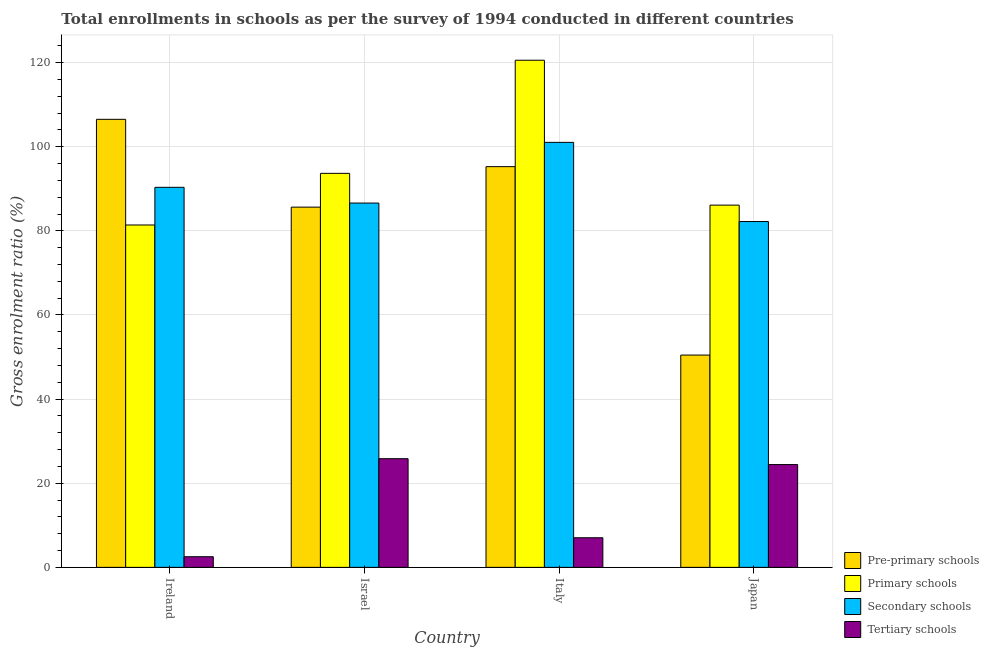How many groups of bars are there?
Keep it short and to the point. 4. Are the number of bars on each tick of the X-axis equal?
Provide a short and direct response. Yes. How many bars are there on the 3rd tick from the left?
Your answer should be compact. 4. How many bars are there on the 3rd tick from the right?
Make the answer very short. 4. What is the gross enrolment ratio in primary schools in Israel?
Provide a succinct answer. 93.68. Across all countries, what is the maximum gross enrolment ratio in pre-primary schools?
Provide a short and direct response. 106.52. Across all countries, what is the minimum gross enrolment ratio in secondary schools?
Provide a succinct answer. 82.22. In which country was the gross enrolment ratio in pre-primary schools maximum?
Make the answer very short. Ireland. In which country was the gross enrolment ratio in tertiary schools minimum?
Ensure brevity in your answer.  Ireland. What is the total gross enrolment ratio in tertiary schools in the graph?
Your answer should be very brief. 59.84. What is the difference between the gross enrolment ratio in tertiary schools in Israel and that in Japan?
Offer a terse response. 1.4. What is the difference between the gross enrolment ratio in tertiary schools in Italy and the gross enrolment ratio in secondary schools in Japan?
Keep it short and to the point. -75.18. What is the average gross enrolment ratio in tertiary schools per country?
Your answer should be compact. 14.96. What is the difference between the gross enrolment ratio in primary schools and gross enrolment ratio in pre-primary schools in Italy?
Provide a succinct answer. 25.3. In how many countries, is the gross enrolment ratio in tertiary schools greater than 60 %?
Provide a succinct answer. 0. What is the ratio of the gross enrolment ratio in secondary schools in Italy to that in Japan?
Offer a very short reply. 1.23. Is the gross enrolment ratio in secondary schools in Israel less than that in Japan?
Offer a very short reply. No. What is the difference between the highest and the second highest gross enrolment ratio in primary schools?
Provide a succinct answer. 26.9. What is the difference between the highest and the lowest gross enrolment ratio in secondary schools?
Provide a succinct answer. 18.82. Is the sum of the gross enrolment ratio in secondary schools in Israel and Japan greater than the maximum gross enrolment ratio in pre-primary schools across all countries?
Make the answer very short. Yes. Is it the case that in every country, the sum of the gross enrolment ratio in pre-primary schools and gross enrolment ratio in secondary schools is greater than the sum of gross enrolment ratio in tertiary schools and gross enrolment ratio in primary schools?
Offer a very short reply. No. What does the 2nd bar from the left in Japan represents?
Offer a terse response. Primary schools. What does the 3rd bar from the right in Ireland represents?
Your answer should be compact. Primary schools. How many bars are there?
Make the answer very short. 16. Are all the bars in the graph horizontal?
Offer a terse response. No. Does the graph contain grids?
Give a very brief answer. Yes. How many legend labels are there?
Your response must be concise. 4. How are the legend labels stacked?
Offer a very short reply. Vertical. What is the title of the graph?
Your answer should be very brief. Total enrollments in schools as per the survey of 1994 conducted in different countries. What is the Gross enrolment ratio (%) in Pre-primary schools in Ireland?
Provide a short and direct response. 106.52. What is the Gross enrolment ratio (%) in Primary schools in Ireland?
Give a very brief answer. 81.4. What is the Gross enrolment ratio (%) of Secondary schools in Ireland?
Offer a very short reply. 90.36. What is the Gross enrolment ratio (%) of Tertiary schools in Ireland?
Offer a terse response. 2.53. What is the Gross enrolment ratio (%) in Pre-primary schools in Israel?
Offer a terse response. 85.65. What is the Gross enrolment ratio (%) of Primary schools in Israel?
Give a very brief answer. 93.68. What is the Gross enrolment ratio (%) of Secondary schools in Israel?
Give a very brief answer. 86.62. What is the Gross enrolment ratio (%) in Tertiary schools in Israel?
Your answer should be very brief. 25.84. What is the Gross enrolment ratio (%) of Pre-primary schools in Italy?
Offer a very short reply. 95.27. What is the Gross enrolment ratio (%) of Primary schools in Italy?
Your answer should be very brief. 120.57. What is the Gross enrolment ratio (%) of Secondary schools in Italy?
Your answer should be compact. 101.04. What is the Gross enrolment ratio (%) of Tertiary schools in Italy?
Your answer should be very brief. 7.04. What is the Gross enrolment ratio (%) of Pre-primary schools in Japan?
Your answer should be compact. 50.47. What is the Gross enrolment ratio (%) of Primary schools in Japan?
Offer a very short reply. 86.13. What is the Gross enrolment ratio (%) in Secondary schools in Japan?
Provide a short and direct response. 82.22. What is the Gross enrolment ratio (%) of Tertiary schools in Japan?
Your answer should be very brief. 24.44. Across all countries, what is the maximum Gross enrolment ratio (%) of Pre-primary schools?
Ensure brevity in your answer.  106.52. Across all countries, what is the maximum Gross enrolment ratio (%) in Primary schools?
Provide a succinct answer. 120.57. Across all countries, what is the maximum Gross enrolment ratio (%) of Secondary schools?
Your answer should be very brief. 101.04. Across all countries, what is the maximum Gross enrolment ratio (%) of Tertiary schools?
Offer a very short reply. 25.84. Across all countries, what is the minimum Gross enrolment ratio (%) in Pre-primary schools?
Provide a succinct answer. 50.47. Across all countries, what is the minimum Gross enrolment ratio (%) of Primary schools?
Ensure brevity in your answer.  81.4. Across all countries, what is the minimum Gross enrolment ratio (%) of Secondary schools?
Provide a succinct answer. 82.22. Across all countries, what is the minimum Gross enrolment ratio (%) of Tertiary schools?
Give a very brief answer. 2.53. What is the total Gross enrolment ratio (%) of Pre-primary schools in the graph?
Offer a terse response. 337.91. What is the total Gross enrolment ratio (%) in Primary schools in the graph?
Provide a short and direct response. 381.77. What is the total Gross enrolment ratio (%) in Secondary schools in the graph?
Make the answer very short. 360.24. What is the total Gross enrolment ratio (%) of Tertiary schools in the graph?
Provide a succinct answer. 59.84. What is the difference between the Gross enrolment ratio (%) of Pre-primary schools in Ireland and that in Israel?
Make the answer very short. 20.88. What is the difference between the Gross enrolment ratio (%) of Primary schools in Ireland and that in Israel?
Ensure brevity in your answer.  -12.28. What is the difference between the Gross enrolment ratio (%) in Secondary schools in Ireland and that in Israel?
Make the answer very short. 3.74. What is the difference between the Gross enrolment ratio (%) in Tertiary schools in Ireland and that in Israel?
Your answer should be very brief. -23.31. What is the difference between the Gross enrolment ratio (%) of Pre-primary schools in Ireland and that in Italy?
Your answer should be compact. 11.25. What is the difference between the Gross enrolment ratio (%) of Primary schools in Ireland and that in Italy?
Keep it short and to the point. -39.17. What is the difference between the Gross enrolment ratio (%) in Secondary schools in Ireland and that in Italy?
Offer a terse response. -10.69. What is the difference between the Gross enrolment ratio (%) in Tertiary schools in Ireland and that in Italy?
Give a very brief answer. -4.51. What is the difference between the Gross enrolment ratio (%) of Pre-primary schools in Ireland and that in Japan?
Give a very brief answer. 56.05. What is the difference between the Gross enrolment ratio (%) in Primary schools in Ireland and that in Japan?
Your answer should be very brief. -4.72. What is the difference between the Gross enrolment ratio (%) in Secondary schools in Ireland and that in Japan?
Provide a short and direct response. 8.13. What is the difference between the Gross enrolment ratio (%) in Tertiary schools in Ireland and that in Japan?
Give a very brief answer. -21.91. What is the difference between the Gross enrolment ratio (%) of Pre-primary schools in Israel and that in Italy?
Give a very brief answer. -9.62. What is the difference between the Gross enrolment ratio (%) in Primary schools in Israel and that in Italy?
Offer a terse response. -26.9. What is the difference between the Gross enrolment ratio (%) of Secondary schools in Israel and that in Italy?
Give a very brief answer. -14.43. What is the difference between the Gross enrolment ratio (%) of Tertiary schools in Israel and that in Italy?
Ensure brevity in your answer.  18.8. What is the difference between the Gross enrolment ratio (%) in Pre-primary schools in Israel and that in Japan?
Make the answer very short. 35.17. What is the difference between the Gross enrolment ratio (%) of Primary schools in Israel and that in Japan?
Keep it short and to the point. 7.55. What is the difference between the Gross enrolment ratio (%) in Secondary schools in Israel and that in Japan?
Ensure brevity in your answer.  4.4. What is the difference between the Gross enrolment ratio (%) of Tertiary schools in Israel and that in Japan?
Make the answer very short. 1.4. What is the difference between the Gross enrolment ratio (%) of Pre-primary schools in Italy and that in Japan?
Keep it short and to the point. 44.8. What is the difference between the Gross enrolment ratio (%) in Primary schools in Italy and that in Japan?
Provide a succinct answer. 34.45. What is the difference between the Gross enrolment ratio (%) of Secondary schools in Italy and that in Japan?
Make the answer very short. 18.82. What is the difference between the Gross enrolment ratio (%) of Tertiary schools in Italy and that in Japan?
Provide a succinct answer. -17.4. What is the difference between the Gross enrolment ratio (%) in Pre-primary schools in Ireland and the Gross enrolment ratio (%) in Primary schools in Israel?
Give a very brief answer. 12.85. What is the difference between the Gross enrolment ratio (%) in Pre-primary schools in Ireland and the Gross enrolment ratio (%) in Secondary schools in Israel?
Your answer should be compact. 19.91. What is the difference between the Gross enrolment ratio (%) in Pre-primary schools in Ireland and the Gross enrolment ratio (%) in Tertiary schools in Israel?
Make the answer very short. 80.69. What is the difference between the Gross enrolment ratio (%) of Primary schools in Ireland and the Gross enrolment ratio (%) of Secondary schools in Israel?
Ensure brevity in your answer.  -5.22. What is the difference between the Gross enrolment ratio (%) in Primary schools in Ireland and the Gross enrolment ratio (%) in Tertiary schools in Israel?
Your answer should be very brief. 55.57. What is the difference between the Gross enrolment ratio (%) in Secondary schools in Ireland and the Gross enrolment ratio (%) in Tertiary schools in Israel?
Give a very brief answer. 64.52. What is the difference between the Gross enrolment ratio (%) in Pre-primary schools in Ireland and the Gross enrolment ratio (%) in Primary schools in Italy?
Offer a very short reply. -14.05. What is the difference between the Gross enrolment ratio (%) of Pre-primary schools in Ireland and the Gross enrolment ratio (%) of Secondary schools in Italy?
Your answer should be compact. 5.48. What is the difference between the Gross enrolment ratio (%) in Pre-primary schools in Ireland and the Gross enrolment ratio (%) in Tertiary schools in Italy?
Keep it short and to the point. 99.49. What is the difference between the Gross enrolment ratio (%) of Primary schools in Ireland and the Gross enrolment ratio (%) of Secondary schools in Italy?
Provide a short and direct response. -19.64. What is the difference between the Gross enrolment ratio (%) of Primary schools in Ireland and the Gross enrolment ratio (%) of Tertiary schools in Italy?
Your answer should be compact. 74.36. What is the difference between the Gross enrolment ratio (%) in Secondary schools in Ireland and the Gross enrolment ratio (%) in Tertiary schools in Italy?
Your response must be concise. 83.32. What is the difference between the Gross enrolment ratio (%) in Pre-primary schools in Ireland and the Gross enrolment ratio (%) in Primary schools in Japan?
Your answer should be compact. 20.4. What is the difference between the Gross enrolment ratio (%) of Pre-primary schools in Ireland and the Gross enrolment ratio (%) of Secondary schools in Japan?
Ensure brevity in your answer.  24.3. What is the difference between the Gross enrolment ratio (%) in Pre-primary schools in Ireland and the Gross enrolment ratio (%) in Tertiary schools in Japan?
Make the answer very short. 82.09. What is the difference between the Gross enrolment ratio (%) in Primary schools in Ireland and the Gross enrolment ratio (%) in Secondary schools in Japan?
Make the answer very short. -0.82. What is the difference between the Gross enrolment ratio (%) of Primary schools in Ireland and the Gross enrolment ratio (%) of Tertiary schools in Japan?
Provide a succinct answer. 56.96. What is the difference between the Gross enrolment ratio (%) of Secondary schools in Ireland and the Gross enrolment ratio (%) of Tertiary schools in Japan?
Give a very brief answer. 65.92. What is the difference between the Gross enrolment ratio (%) of Pre-primary schools in Israel and the Gross enrolment ratio (%) of Primary schools in Italy?
Keep it short and to the point. -34.93. What is the difference between the Gross enrolment ratio (%) of Pre-primary schools in Israel and the Gross enrolment ratio (%) of Secondary schools in Italy?
Offer a very short reply. -15.4. What is the difference between the Gross enrolment ratio (%) in Pre-primary schools in Israel and the Gross enrolment ratio (%) in Tertiary schools in Italy?
Ensure brevity in your answer.  78.61. What is the difference between the Gross enrolment ratio (%) of Primary schools in Israel and the Gross enrolment ratio (%) of Secondary schools in Italy?
Make the answer very short. -7.37. What is the difference between the Gross enrolment ratio (%) in Primary schools in Israel and the Gross enrolment ratio (%) in Tertiary schools in Italy?
Make the answer very short. 86.64. What is the difference between the Gross enrolment ratio (%) in Secondary schools in Israel and the Gross enrolment ratio (%) in Tertiary schools in Italy?
Your answer should be compact. 79.58. What is the difference between the Gross enrolment ratio (%) in Pre-primary schools in Israel and the Gross enrolment ratio (%) in Primary schools in Japan?
Provide a short and direct response. -0.48. What is the difference between the Gross enrolment ratio (%) in Pre-primary schools in Israel and the Gross enrolment ratio (%) in Secondary schools in Japan?
Make the answer very short. 3.43. What is the difference between the Gross enrolment ratio (%) of Pre-primary schools in Israel and the Gross enrolment ratio (%) of Tertiary schools in Japan?
Offer a terse response. 61.21. What is the difference between the Gross enrolment ratio (%) of Primary schools in Israel and the Gross enrolment ratio (%) of Secondary schools in Japan?
Your response must be concise. 11.46. What is the difference between the Gross enrolment ratio (%) of Primary schools in Israel and the Gross enrolment ratio (%) of Tertiary schools in Japan?
Keep it short and to the point. 69.24. What is the difference between the Gross enrolment ratio (%) in Secondary schools in Israel and the Gross enrolment ratio (%) in Tertiary schools in Japan?
Your response must be concise. 62.18. What is the difference between the Gross enrolment ratio (%) of Pre-primary schools in Italy and the Gross enrolment ratio (%) of Primary schools in Japan?
Your response must be concise. 9.14. What is the difference between the Gross enrolment ratio (%) in Pre-primary schools in Italy and the Gross enrolment ratio (%) in Secondary schools in Japan?
Make the answer very short. 13.05. What is the difference between the Gross enrolment ratio (%) in Pre-primary schools in Italy and the Gross enrolment ratio (%) in Tertiary schools in Japan?
Your answer should be very brief. 70.83. What is the difference between the Gross enrolment ratio (%) in Primary schools in Italy and the Gross enrolment ratio (%) in Secondary schools in Japan?
Your answer should be very brief. 38.35. What is the difference between the Gross enrolment ratio (%) of Primary schools in Italy and the Gross enrolment ratio (%) of Tertiary schools in Japan?
Make the answer very short. 96.13. What is the difference between the Gross enrolment ratio (%) of Secondary schools in Italy and the Gross enrolment ratio (%) of Tertiary schools in Japan?
Your answer should be very brief. 76.6. What is the average Gross enrolment ratio (%) of Pre-primary schools per country?
Provide a short and direct response. 84.48. What is the average Gross enrolment ratio (%) of Primary schools per country?
Offer a very short reply. 95.44. What is the average Gross enrolment ratio (%) of Secondary schools per country?
Offer a terse response. 90.06. What is the average Gross enrolment ratio (%) in Tertiary schools per country?
Provide a short and direct response. 14.96. What is the difference between the Gross enrolment ratio (%) in Pre-primary schools and Gross enrolment ratio (%) in Primary schools in Ireland?
Your response must be concise. 25.12. What is the difference between the Gross enrolment ratio (%) of Pre-primary schools and Gross enrolment ratio (%) of Secondary schools in Ireland?
Keep it short and to the point. 16.17. What is the difference between the Gross enrolment ratio (%) in Pre-primary schools and Gross enrolment ratio (%) in Tertiary schools in Ireland?
Ensure brevity in your answer.  104. What is the difference between the Gross enrolment ratio (%) of Primary schools and Gross enrolment ratio (%) of Secondary schools in Ireland?
Offer a terse response. -8.95. What is the difference between the Gross enrolment ratio (%) of Primary schools and Gross enrolment ratio (%) of Tertiary schools in Ireland?
Make the answer very short. 78.87. What is the difference between the Gross enrolment ratio (%) in Secondary schools and Gross enrolment ratio (%) in Tertiary schools in Ireland?
Provide a short and direct response. 87.83. What is the difference between the Gross enrolment ratio (%) in Pre-primary schools and Gross enrolment ratio (%) in Primary schools in Israel?
Your response must be concise. -8.03. What is the difference between the Gross enrolment ratio (%) in Pre-primary schools and Gross enrolment ratio (%) in Secondary schools in Israel?
Make the answer very short. -0.97. What is the difference between the Gross enrolment ratio (%) of Pre-primary schools and Gross enrolment ratio (%) of Tertiary schools in Israel?
Your response must be concise. 59.81. What is the difference between the Gross enrolment ratio (%) in Primary schools and Gross enrolment ratio (%) in Secondary schools in Israel?
Your answer should be compact. 7.06. What is the difference between the Gross enrolment ratio (%) in Primary schools and Gross enrolment ratio (%) in Tertiary schools in Israel?
Give a very brief answer. 67.84. What is the difference between the Gross enrolment ratio (%) of Secondary schools and Gross enrolment ratio (%) of Tertiary schools in Israel?
Make the answer very short. 60.78. What is the difference between the Gross enrolment ratio (%) in Pre-primary schools and Gross enrolment ratio (%) in Primary schools in Italy?
Ensure brevity in your answer.  -25.3. What is the difference between the Gross enrolment ratio (%) in Pre-primary schools and Gross enrolment ratio (%) in Secondary schools in Italy?
Provide a succinct answer. -5.77. What is the difference between the Gross enrolment ratio (%) in Pre-primary schools and Gross enrolment ratio (%) in Tertiary schools in Italy?
Provide a short and direct response. 88.23. What is the difference between the Gross enrolment ratio (%) of Primary schools and Gross enrolment ratio (%) of Secondary schools in Italy?
Provide a succinct answer. 19.53. What is the difference between the Gross enrolment ratio (%) in Primary schools and Gross enrolment ratio (%) in Tertiary schools in Italy?
Your response must be concise. 113.53. What is the difference between the Gross enrolment ratio (%) in Secondary schools and Gross enrolment ratio (%) in Tertiary schools in Italy?
Give a very brief answer. 94.01. What is the difference between the Gross enrolment ratio (%) in Pre-primary schools and Gross enrolment ratio (%) in Primary schools in Japan?
Offer a terse response. -35.65. What is the difference between the Gross enrolment ratio (%) in Pre-primary schools and Gross enrolment ratio (%) in Secondary schools in Japan?
Offer a terse response. -31.75. What is the difference between the Gross enrolment ratio (%) in Pre-primary schools and Gross enrolment ratio (%) in Tertiary schools in Japan?
Ensure brevity in your answer.  26.03. What is the difference between the Gross enrolment ratio (%) in Primary schools and Gross enrolment ratio (%) in Secondary schools in Japan?
Offer a very short reply. 3.9. What is the difference between the Gross enrolment ratio (%) of Primary schools and Gross enrolment ratio (%) of Tertiary schools in Japan?
Give a very brief answer. 61.69. What is the difference between the Gross enrolment ratio (%) in Secondary schools and Gross enrolment ratio (%) in Tertiary schools in Japan?
Provide a short and direct response. 57.78. What is the ratio of the Gross enrolment ratio (%) of Pre-primary schools in Ireland to that in Israel?
Offer a terse response. 1.24. What is the ratio of the Gross enrolment ratio (%) of Primary schools in Ireland to that in Israel?
Ensure brevity in your answer.  0.87. What is the ratio of the Gross enrolment ratio (%) in Secondary schools in Ireland to that in Israel?
Your answer should be compact. 1.04. What is the ratio of the Gross enrolment ratio (%) in Tertiary schools in Ireland to that in Israel?
Make the answer very short. 0.1. What is the ratio of the Gross enrolment ratio (%) of Pre-primary schools in Ireland to that in Italy?
Provide a short and direct response. 1.12. What is the ratio of the Gross enrolment ratio (%) of Primary schools in Ireland to that in Italy?
Your answer should be compact. 0.68. What is the ratio of the Gross enrolment ratio (%) of Secondary schools in Ireland to that in Italy?
Your answer should be very brief. 0.89. What is the ratio of the Gross enrolment ratio (%) of Tertiary schools in Ireland to that in Italy?
Give a very brief answer. 0.36. What is the ratio of the Gross enrolment ratio (%) of Pre-primary schools in Ireland to that in Japan?
Offer a very short reply. 2.11. What is the ratio of the Gross enrolment ratio (%) in Primary schools in Ireland to that in Japan?
Make the answer very short. 0.95. What is the ratio of the Gross enrolment ratio (%) of Secondary schools in Ireland to that in Japan?
Your answer should be very brief. 1.1. What is the ratio of the Gross enrolment ratio (%) in Tertiary schools in Ireland to that in Japan?
Offer a very short reply. 0.1. What is the ratio of the Gross enrolment ratio (%) in Pre-primary schools in Israel to that in Italy?
Offer a terse response. 0.9. What is the ratio of the Gross enrolment ratio (%) of Primary schools in Israel to that in Italy?
Keep it short and to the point. 0.78. What is the ratio of the Gross enrolment ratio (%) of Secondary schools in Israel to that in Italy?
Offer a very short reply. 0.86. What is the ratio of the Gross enrolment ratio (%) in Tertiary schools in Israel to that in Italy?
Your answer should be compact. 3.67. What is the ratio of the Gross enrolment ratio (%) of Pre-primary schools in Israel to that in Japan?
Offer a terse response. 1.7. What is the ratio of the Gross enrolment ratio (%) in Primary schools in Israel to that in Japan?
Give a very brief answer. 1.09. What is the ratio of the Gross enrolment ratio (%) of Secondary schools in Israel to that in Japan?
Ensure brevity in your answer.  1.05. What is the ratio of the Gross enrolment ratio (%) of Tertiary schools in Israel to that in Japan?
Give a very brief answer. 1.06. What is the ratio of the Gross enrolment ratio (%) of Pre-primary schools in Italy to that in Japan?
Your response must be concise. 1.89. What is the ratio of the Gross enrolment ratio (%) in Primary schools in Italy to that in Japan?
Keep it short and to the point. 1.4. What is the ratio of the Gross enrolment ratio (%) of Secondary schools in Italy to that in Japan?
Provide a short and direct response. 1.23. What is the ratio of the Gross enrolment ratio (%) of Tertiary schools in Italy to that in Japan?
Offer a terse response. 0.29. What is the difference between the highest and the second highest Gross enrolment ratio (%) of Pre-primary schools?
Your answer should be compact. 11.25. What is the difference between the highest and the second highest Gross enrolment ratio (%) in Primary schools?
Provide a succinct answer. 26.9. What is the difference between the highest and the second highest Gross enrolment ratio (%) in Secondary schools?
Offer a terse response. 10.69. What is the difference between the highest and the second highest Gross enrolment ratio (%) in Tertiary schools?
Give a very brief answer. 1.4. What is the difference between the highest and the lowest Gross enrolment ratio (%) of Pre-primary schools?
Make the answer very short. 56.05. What is the difference between the highest and the lowest Gross enrolment ratio (%) in Primary schools?
Provide a succinct answer. 39.17. What is the difference between the highest and the lowest Gross enrolment ratio (%) in Secondary schools?
Your answer should be compact. 18.82. What is the difference between the highest and the lowest Gross enrolment ratio (%) in Tertiary schools?
Provide a succinct answer. 23.31. 